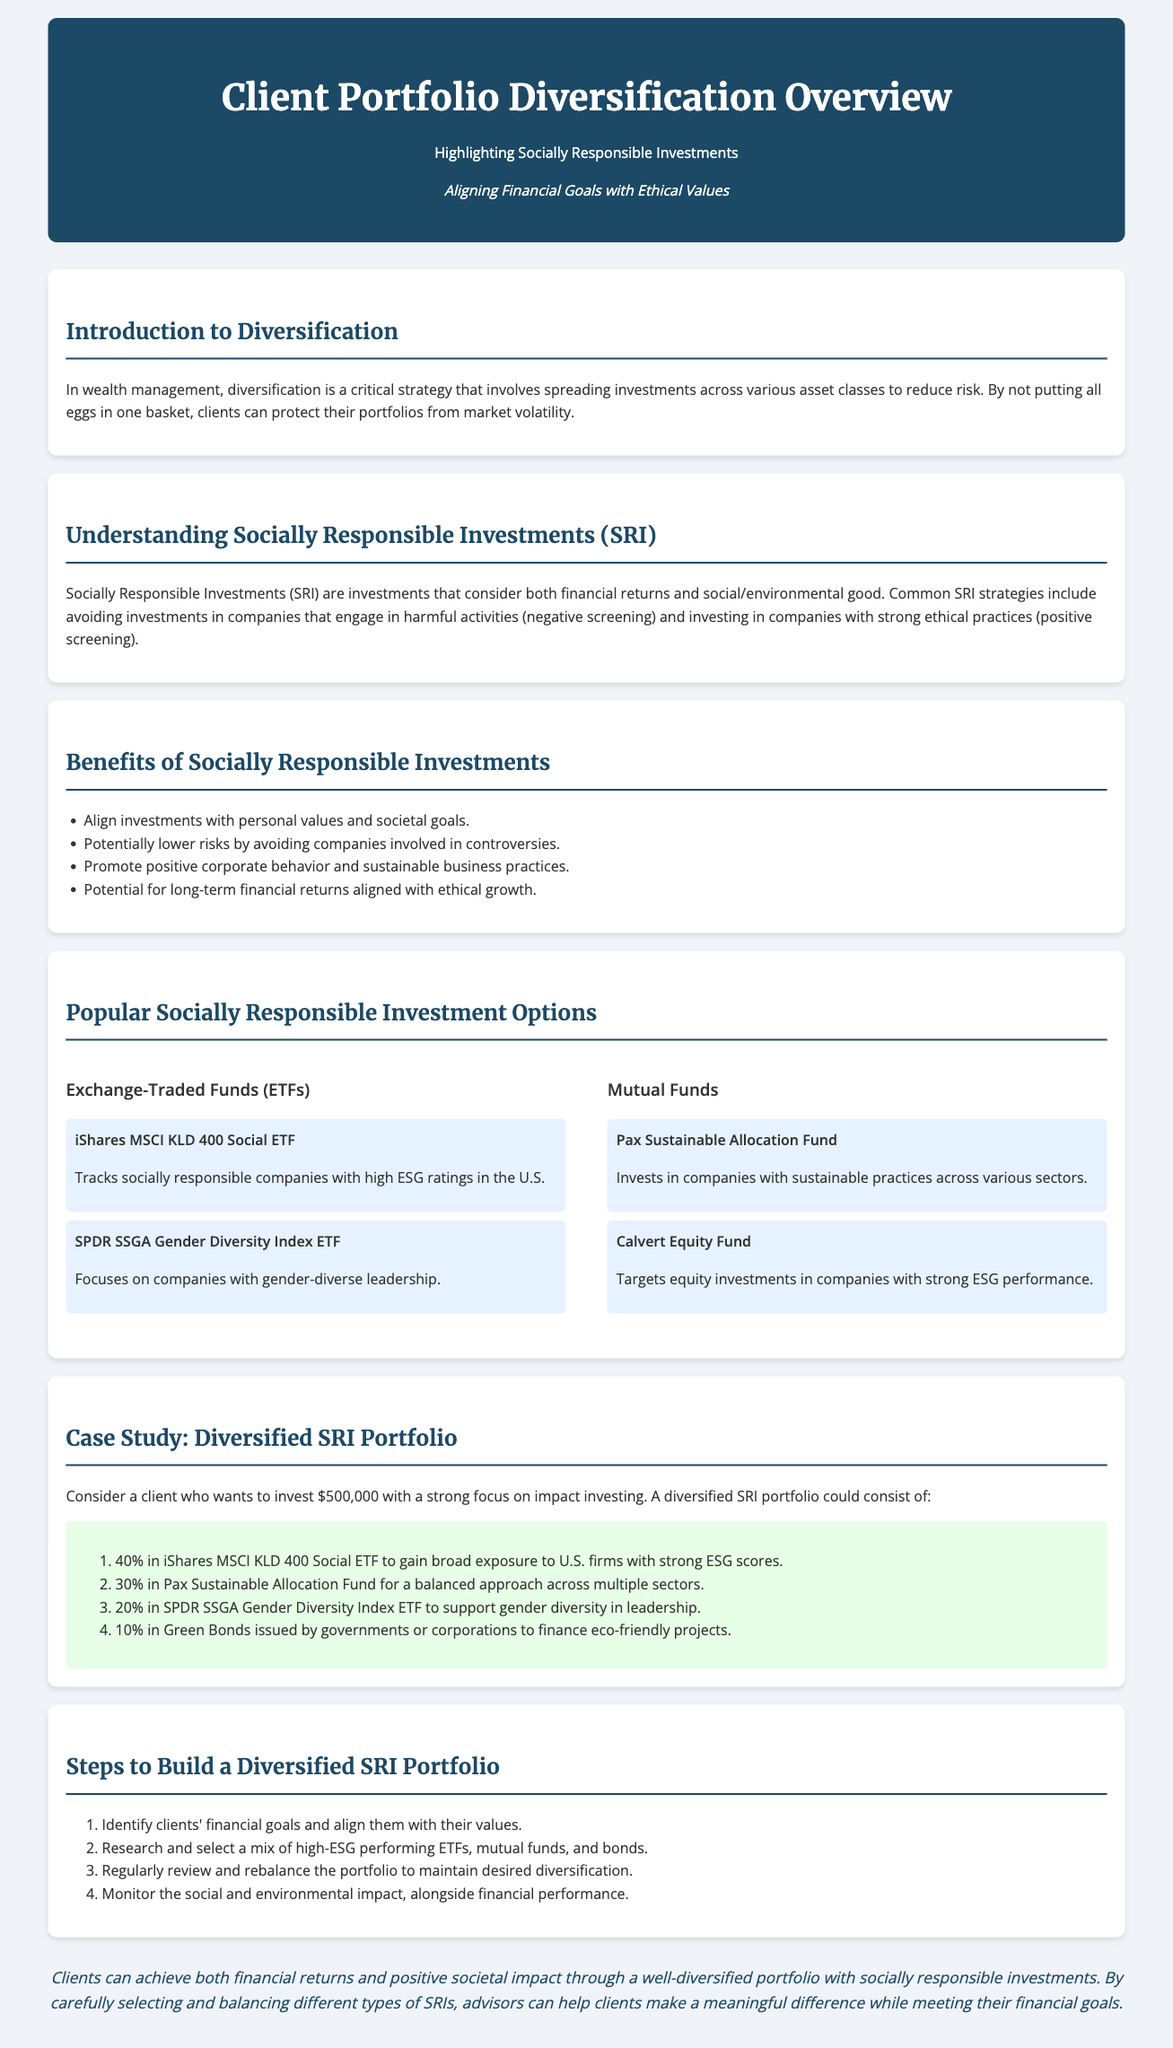What is the main focus of the document? The main focus is on Client Portfolio Diversification with an emphasis on Socially Responsible Investments.
Answer: Socially Responsible Investments What percentage of the hypothetical SRI portfolio is allocated to Green Bonds? The document specifies an allocation of 10% towards Green Bonds in the proposed SRI portfolio case study.
Answer: 10% What are the two types of investment options listed under Socially Responsible Investments? The two types of investment options included are Exchange-Traded Funds (ETFs) and Mutual Funds.
Answer: Exchange-Traded Funds (ETFs) and Mutual Funds What is the first step to building a diversified SRI portfolio? The first step involves identifying clients' financial goals and aligning them with their values.
Answer: Identify clients' financial goals Which fund focuses on gender diversity in leadership? The SPDR SSGA Gender Diversity Index ETF targets companies with gender-diverse leadership.
Answer: SPDR SSGA Gender Diversity Index ETF What is one benefit of Socially Responsible Investments mentioned in the document? One benefit highlighted is the potential for long-term financial returns aligned with ethical growth.
Answer: Potential for long-term financial returns How much money is the hypothetical client planning to invest? The hypothetical client is looking to invest $500,000 as mentioned in the case study section.
Answer: $500,000 What type of environmental projects do Green Bonds finance? Green Bonds are issued to finance eco-friendly projects, according to the document.
Answer: Eco-friendly projects 